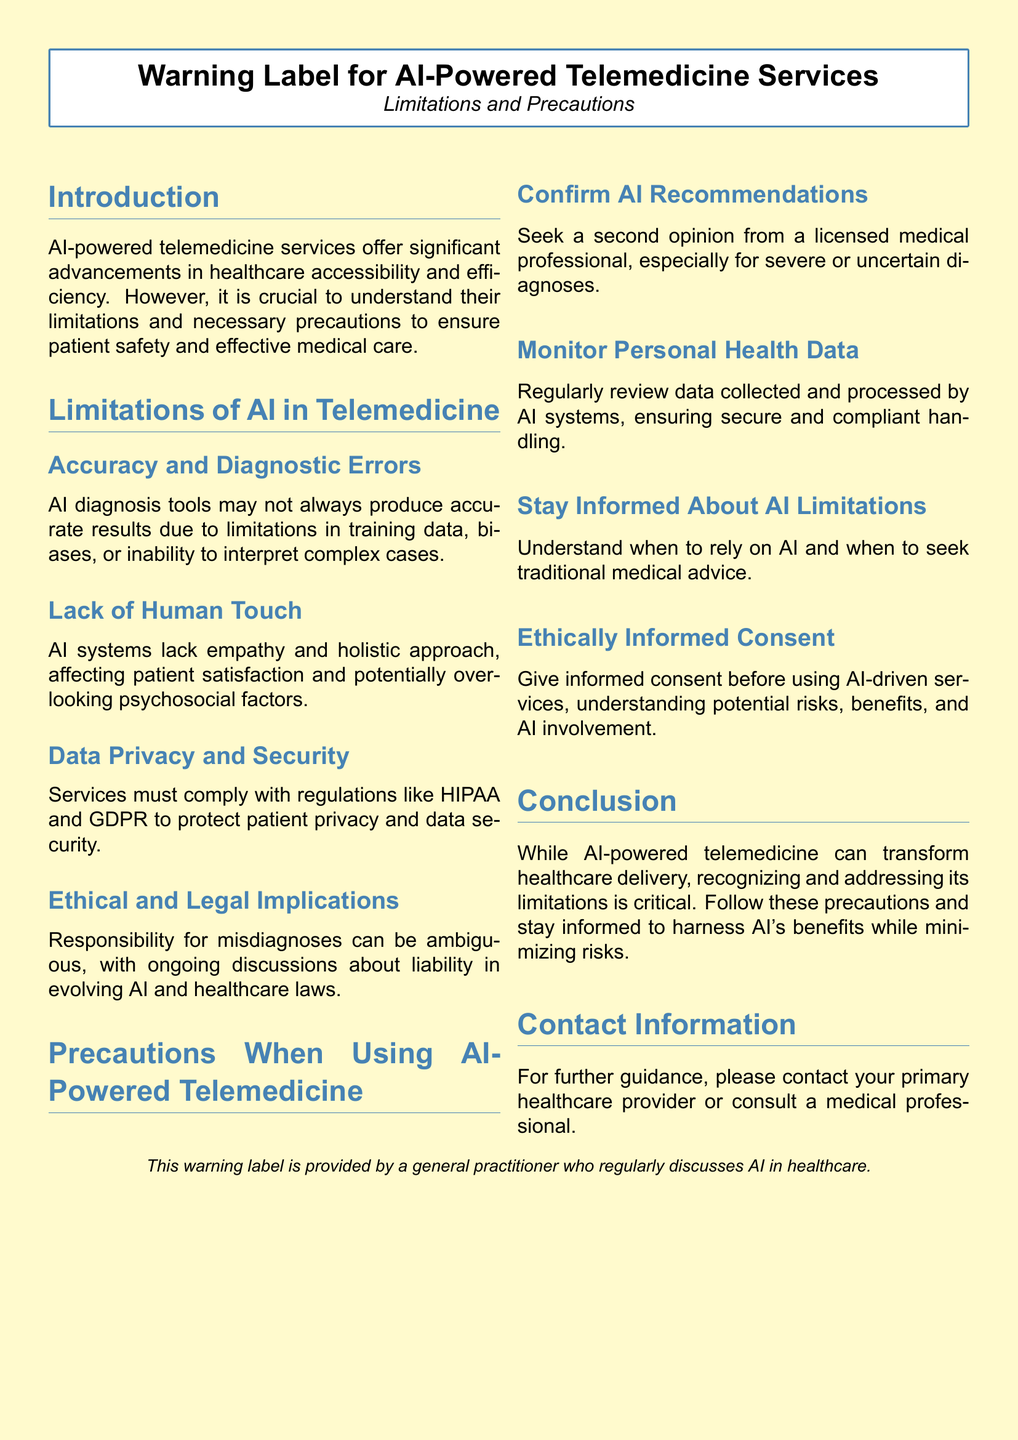What is the title of the document? The title of the document is prominently displayed at the top and indicates its focus on AI-powered telemedicine services.
Answer: Warning Label for AI-Powered Telemedicine Services What is one limitation mentioned about AI in telemedicine? The document lists several limitations, including issues related to accuracy and human interaction.
Answer: Accuracy and Diagnostic Errors What regulation is mentioned regarding data privacy? The document emphasizes the importance of compliance with certain regulations to protect patient data.
Answer: HIPAA and GDPR What should patients do with AI recommendations? The precautionary advice suggests seeking further consultation to corroborate AI's output.
Answer: Seek a second opinion What is highlighted as lacking in AI systems? The document identifies a specific element that AI systems do not possess, affecting patient interaction.
Answer: Human Touch What is required before using AI-driven services? The document emphasizes the need for an action to ensure patients are aware of potential risks associated with AI tools.
Answer: Ethically Informed Consent What does the conclusion state about AI-powered telemedicine? The conclusion summarizes the overall perspective on AI's role and associated caution in healthcare.
Answer: Recognizing and addressing its limitations is critical How should patients monitor their personal health data? The document suggests a specific action regarding the oversight of health-related information gathered by AI tools.
Answer: Regularly review data collected 